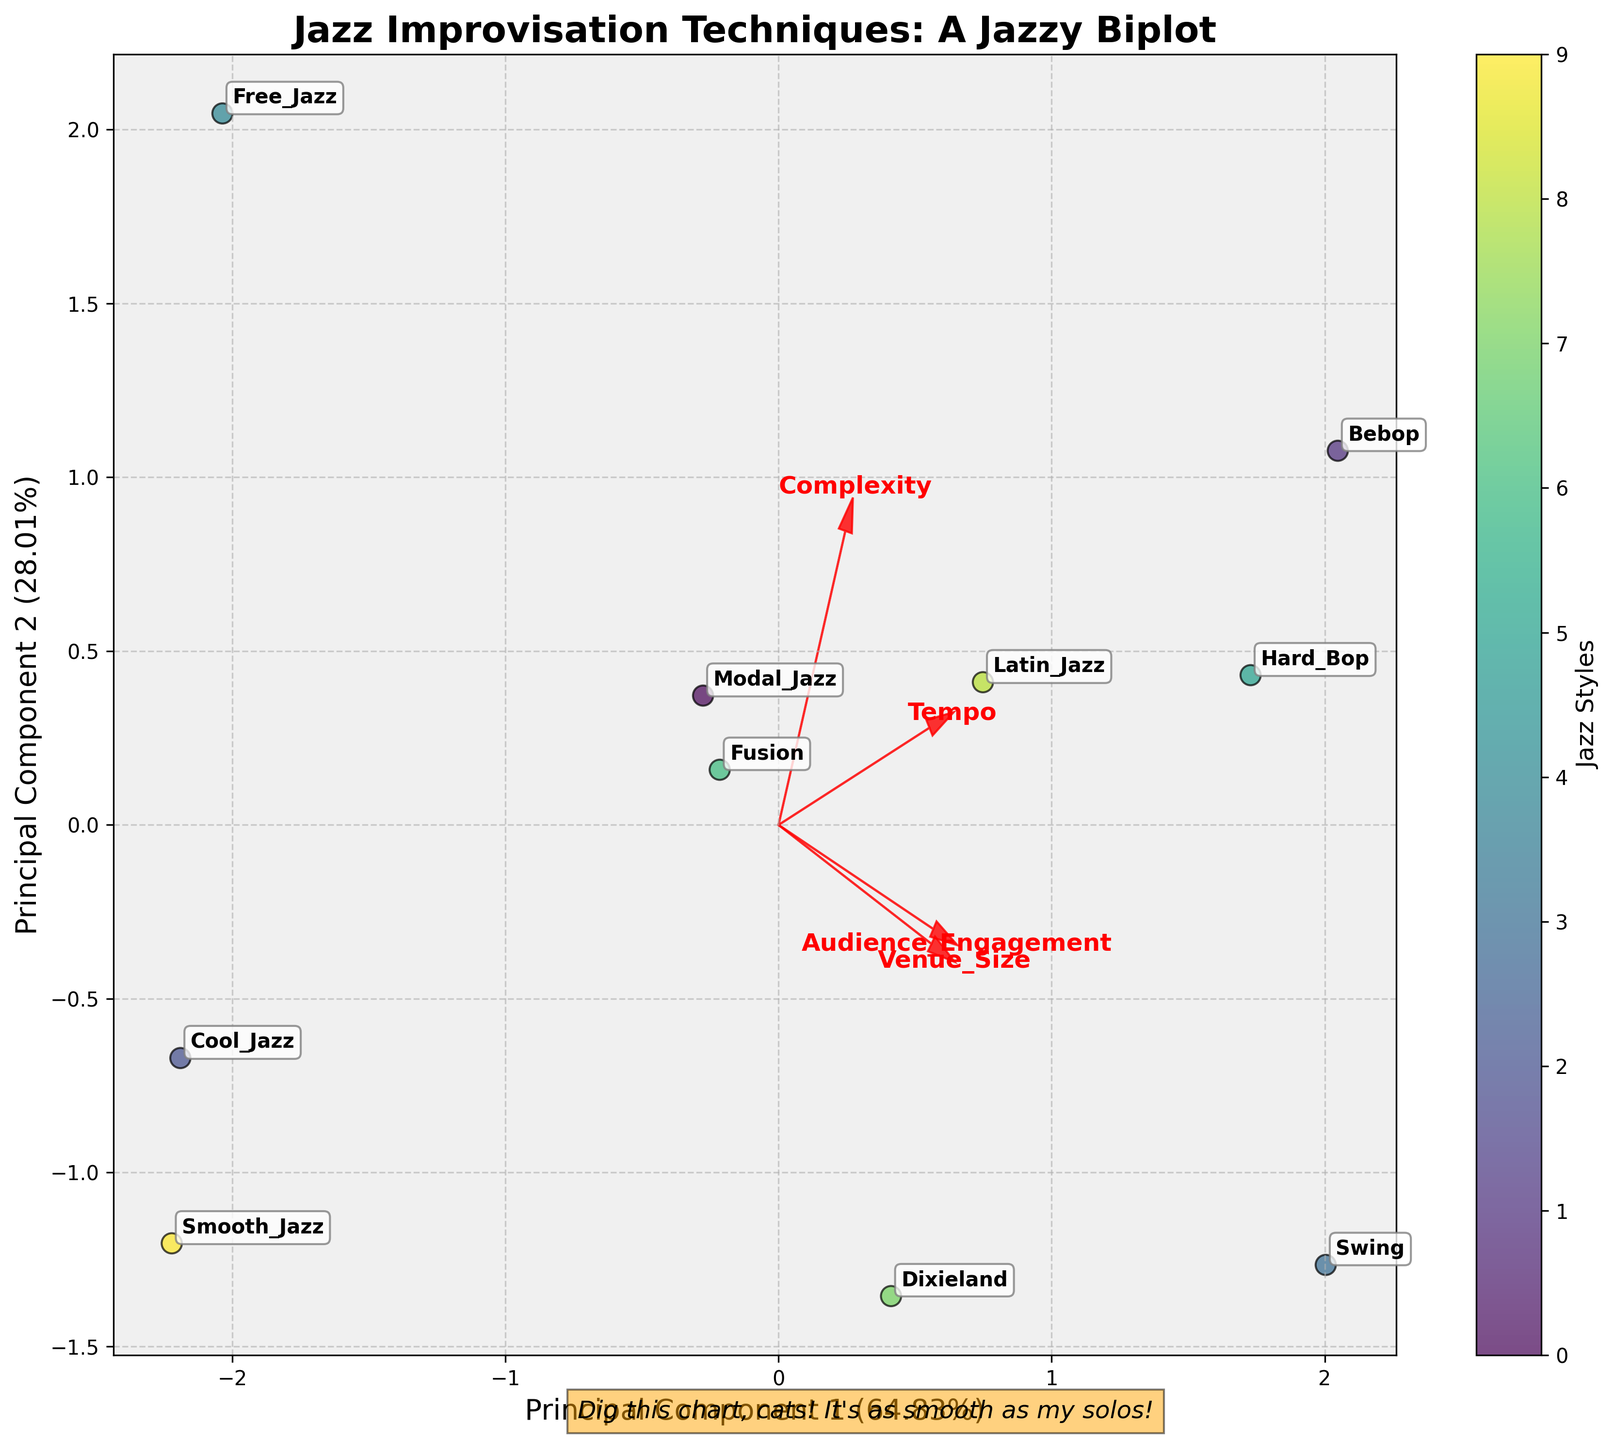what's the title of the biplot? The title of a plot is typically found at the top center of the figure, and it often summarizes the subject of the visualization. In this case, the title is "Jazz Improvisation Techniques: A Jazzy Biplot".
Answer: Jazz Improvisation Techniques: A Jazzy Biplot How many jazz improvisation techniques are represented in the biplot? Look for the number of unique labels annotated around the data points; each label represents a different jazz improvisation technique. There are 10 different techniques labeled in the plot.
Answer: 10 Which technique has the highest audience engagement according to the biplot? Check the data points to see which one corresponds to the highest value on the Audience Engagement axis. The technique 'Swing' is noted to have the highest audience engagement.
Answer: Swing How are the features 'Tempo' and 'Complexity' represented in the biplot? Look at the red arrows starting from the origin. Each arrow points in the direction of increasing value for the corresponding feature. 'Tempo' and 'Complexity' are represented by two of these arrows.
Answer: Red arrows Which two techniques seem to be most similar based on the biplot? Look for data points that are close to each other on the plot. 'Bebop' and 'Latin_Jazz' appear to be very close, indicating that they share similar characteristics in terms of the features analyzed.
Answer: Bebop and Latin_Jazz What's the explained variance of the first principal component? Observe the x-axis label which includes the explained variance percentage for PC1. The explained variance of the first principal component is 55.07%.
Answer: 55.07% Between 'Modal_Jazz' and 'Cool_Jazz,' which technique is performed in larger venues according to the biplot? Compare the transformed values of the 'Venue_Size' component. The data point for 'Modal_Jazz' is positioned further along the 'Venue_Size' arrow than 'Cool_Jazz,' indicating larger venues.
Answer: Modal_Jazz Which feature has the least influence on the principal components based on the length of the arrows in the biplot? The feature represented by the shortest arrow has the least influence. In the plot, 'Tempo' appears to be represented by the shortest red arrow.
Answer: Tempo How much variance is explained by the second principal component? Look at the y-axis label, which indicates the explained variance percentage for PC2. The second principal component explains 24.51% of the variance.
Answer: 24.51% What message is displayed at the bottom of the biplot? The message is usually a small caption or annotation at the bottom of the figure. It reads "Dig this chart, cats! It's as smooth as my solos!"
Answer: Dig this chart, cats! It's as smooth as my solos! 